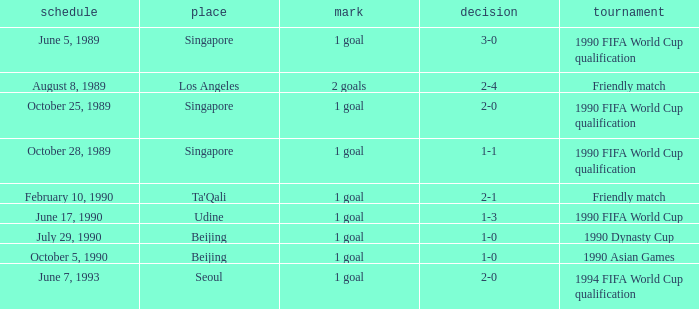What is the venue of the 1990 Asian games? Beijing. 